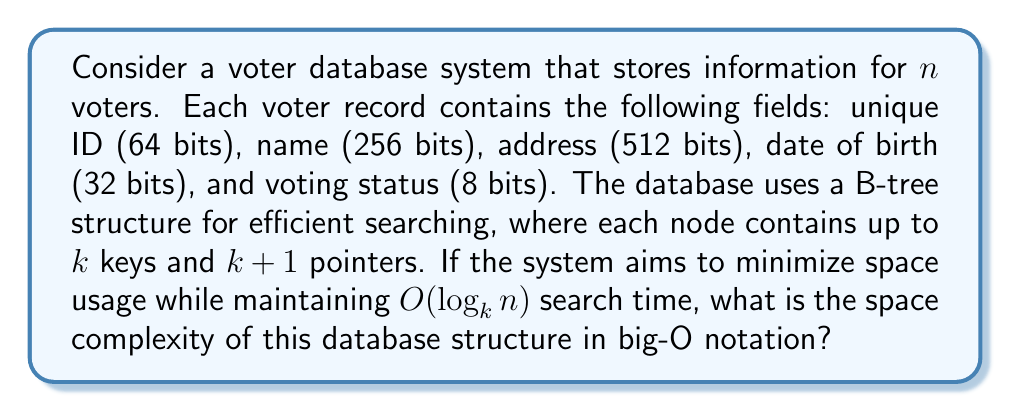Help me with this question. To determine the space complexity, we need to consider both the space required for storing the voter records and the B-tree structure:

1. Space for voter records:
   - Each voter record requires: 64 + 256 + 512 + 32 + 8 = 872 bits = 109 bytes
   - Total space for $n$ voters: $109n$ bytes

2. Space for B-tree structure:
   - Each node in the B-tree contains:
     * Up to $k$ keys (each key is a 64-bit voter ID): $8k$ bytes
     * Up to $k+1$ pointers (assuming 64-bit addresses): $8(k+1)$ bytes
   - Total space per node: $8k + 8(k+1) = 16k + 8$ bytes
   - Number of nodes in a B-tree of height $h$: $O(k^h)$
   - The height $h$ of the B-tree is $O(\log_k n)$ to maintain $O(\log_k n)$ search time

   Therefore, the total space for the B-tree structure is:
   $O((16k + 8) \cdot k^{\log_k n}) = O(k \cdot n)$ bytes

3. Total space complexity:
   $O(109n + kn) = O((109+k)n) = O(n)$ bytes

The constant factors and $k$ can be considered as fixed values, so they don't affect the big-O notation.
Answer: The space complexity of the voter database system is $O(n)$, where $n$ is the number of voters. 